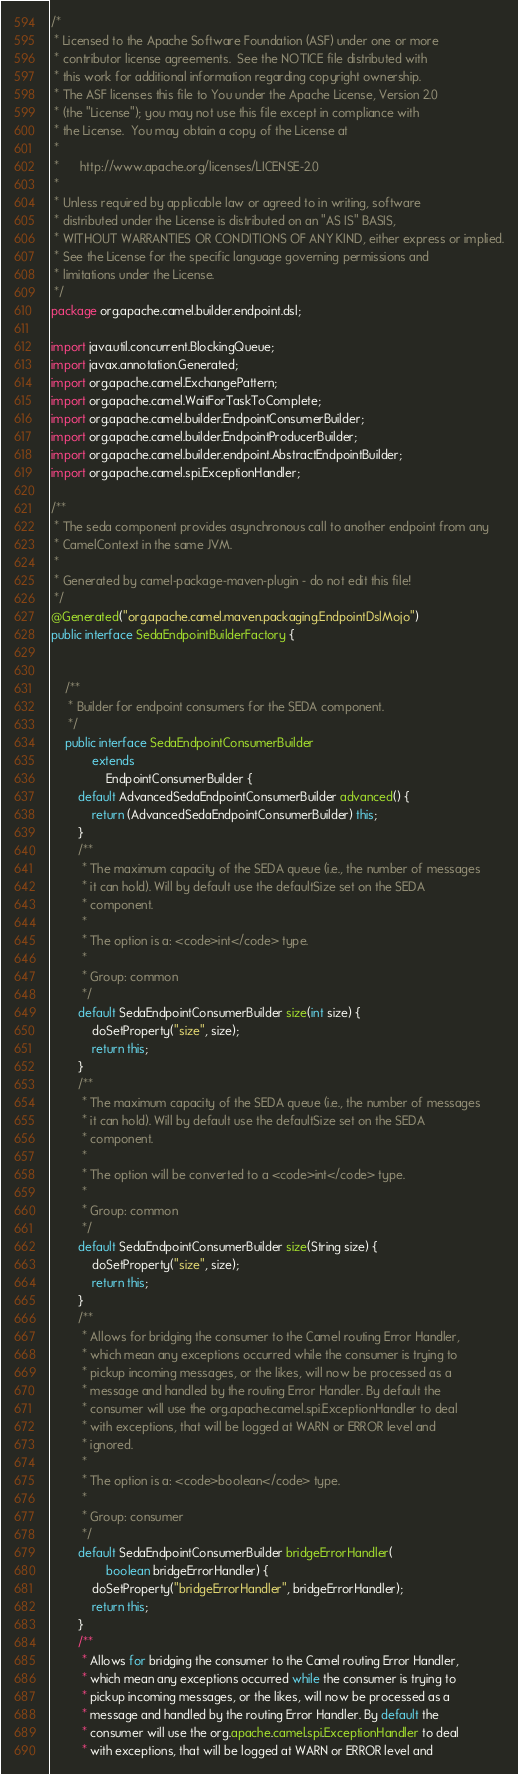<code> <loc_0><loc_0><loc_500><loc_500><_Java_>/*
 * Licensed to the Apache Software Foundation (ASF) under one or more
 * contributor license agreements.  See the NOTICE file distributed with
 * this work for additional information regarding copyright ownership.
 * The ASF licenses this file to You under the Apache License, Version 2.0
 * (the "License"); you may not use this file except in compliance with
 * the License.  You may obtain a copy of the License at
 *
 *      http://www.apache.org/licenses/LICENSE-2.0
 *
 * Unless required by applicable law or agreed to in writing, software
 * distributed under the License is distributed on an "AS IS" BASIS,
 * WITHOUT WARRANTIES OR CONDITIONS OF ANY KIND, either express or implied.
 * See the License for the specific language governing permissions and
 * limitations under the License.
 */
package org.apache.camel.builder.endpoint.dsl;

import java.util.concurrent.BlockingQueue;
import javax.annotation.Generated;
import org.apache.camel.ExchangePattern;
import org.apache.camel.WaitForTaskToComplete;
import org.apache.camel.builder.EndpointConsumerBuilder;
import org.apache.camel.builder.EndpointProducerBuilder;
import org.apache.camel.builder.endpoint.AbstractEndpointBuilder;
import org.apache.camel.spi.ExceptionHandler;

/**
 * The seda component provides asynchronous call to another endpoint from any
 * CamelContext in the same JVM.
 * 
 * Generated by camel-package-maven-plugin - do not edit this file!
 */
@Generated("org.apache.camel.maven.packaging.EndpointDslMojo")
public interface SedaEndpointBuilderFactory {


    /**
     * Builder for endpoint consumers for the SEDA component.
     */
    public interface SedaEndpointConsumerBuilder
            extends
                EndpointConsumerBuilder {
        default AdvancedSedaEndpointConsumerBuilder advanced() {
            return (AdvancedSedaEndpointConsumerBuilder) this;
        }
        /**
         * The maximum capacity of the SEDA queue (i.e., the number of messages
         * it can hold). Will by default use the defaultSize set on the SEDA
         * component.
         * 
         * The option is a: <code>int</code> type.
         * 
         * Group: common
         */
        default SedaEndpointConsumerBuilder size(int size) {
            doSetProperty("size", size);
            return this;
        }
        /**
         * The maximum capacity of the SEDA queue (i.e., the number of messages
         * it can hold). Will by default use the defaultSize set on the SEDA
         * component.
         * 
         * The option will be converted to a <code>int</code> type.
         * 
         * Group: common
         */
        default SedaEndpointConsumerBuilder size(String size) {
            doSetProperty("size", size);
            return this;
        }
        /**
         * Allows for bridging the consumer to the Camel routing Error Handler,
         * which mean any exceptions occurred while the consumer is trying to
         * pickup incoming messages, or the likes, will now be processed as a
         * message and handled by the routing Error Handler. By default the
         * consumer will use the org.apache.camel.spi.ExceptionHandler to deal
         * with exceptions, that will be logged at WARN or ERROR level and
         * ignored.
         * 
         * The option is a: <code>boolean</code> type.
         * 
         * Group: consumer
         */
        default SedaEndpointConsumerBuilder bridgeErrorHandler(
                boolean bridgeErrorHandler) {
            doSetProperty("bridgeErrorHandler", bridgeErrorHandler);
            return this;
        }
        /**
         * Allows for bridging the consumer to the Camel routing Error Handler,
         * which mean any exceptions occurred while the consumer is trying to
         * pickup incoming messages, or the likes, will now be processed as a
         * message and handled by the routing Error Handler. By default the
         * consumer will use the org.apache.camel.spi.ExceptionHandler to deal
         * with exceptions, that will be logged at WARN or ERROR level and</code> 